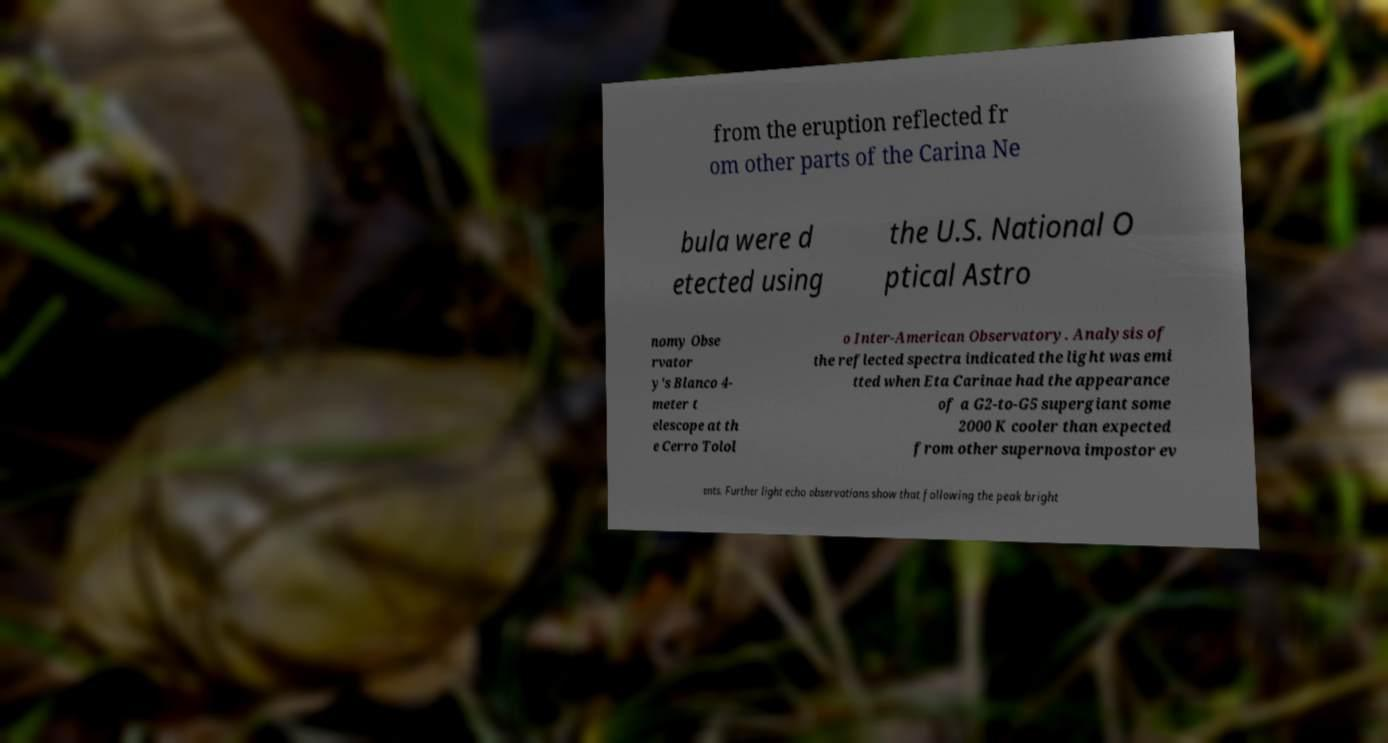I need the written content from this picture converted into text. Can you do that? from the eruption reflected fr om other parts of the Carina Ne bula were d etected using the U.S. National O ptical Astro nomy Obse rvator y's Blanco 4- meter t elescope at th e Cerro Tolol o Inter-American Observatory. Analysis of the reflected spectra indicated the light was emi tted when Eta Carinae had the appearance of a G2-to-G5 supergiant some 2000 K cooler than expected from other supernova impostor ev ents. Further light echo observations show that following the peak bright 